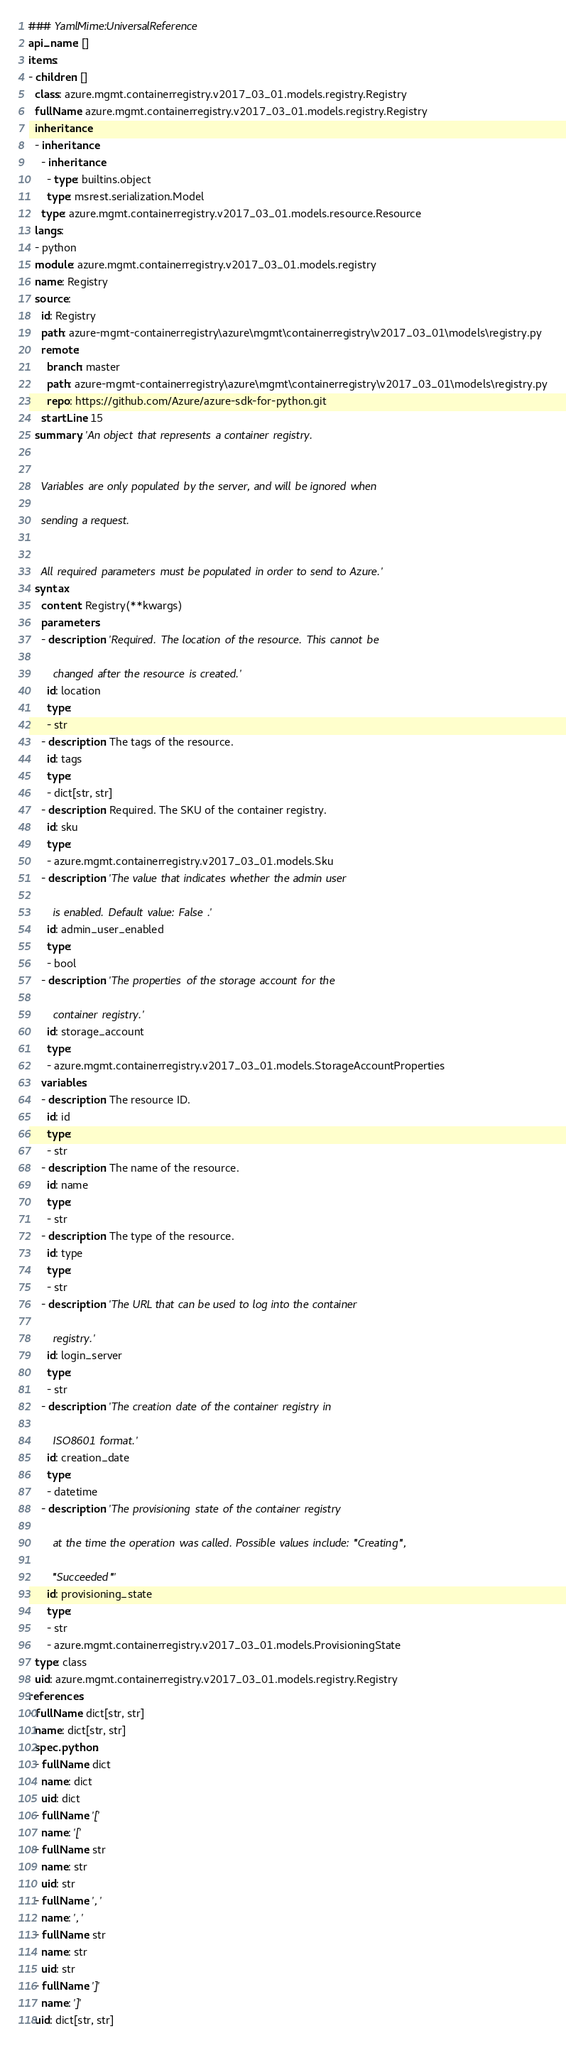Convert code to text. <code><loc_0><loc_0><loc_500><loc_500><_YAML_>### YamlMime:UniversalReference
api_name: []
items:
- children: []
  class: azure.mgmt.containerregistry.v2017_03_01.models.registry.Registry
  fullName: azure.mgmt.containerregistry.v2017_03_01.models.registry.Registry
  inheritance:
  - inheritance:
    - inheritance:
      - type: builtins.object
      type: msrest.serialization.Model
    type: azure.mgmt.containerregistry.v2017_03_01.models.resource.Resource
  langs:
  - python
  module: azure.mgmt.containerregistry.v2017_03_01.models.registry
  name: Registry
  source:
    id: Registry
    path: azure-mgmt-containerregistry\azure\mgmt\containerregistry\v2017_03_01\models\registry.py
    remote:
      branch: master
      path: azure-mgmt-containerregistry\azure\mgmt\containerregistry\v2017_03_01\models\registry.py
      repo: https://github.com/Azure/azure-sdk-for-python.git
    startLine: 15
  summary: 'An object that represents a container registry.


    Variables are only populated by the server, and will be ignored when

    sending a request.


    All required parameters must be populated in order to send to Azure.'
  syntax:
    content: Registry(**kwargs)
    parameters:
    - description: 'Required. The location of the resource. This cannot be

        changed after the resource is created.'
      id: location
      type:
      - str
    - description: The tags of the resource.
      id: tags
      type:
      - dict[str, str]
    - description: Required. The SKU of the container registry.
      id: sku
      type:
      - azure.mgmt.containerregistry.v2017_03_01.models.Sku
    - description: 'The value that indicates whether the admin user

        is enabled. Default value: False .'
      id: admin_user_enabled
      type:
      - bool
    - description: 'The properties of the storage account for the

        container registry.'
      id: storage_account
      type:
      - azure.mgmt.containerregistry.v2017_03_01.models.StorageAccountProperties
    variables:
    - description: The resource ID.
      id: id
      type:
      - str
    - description: The name of the resource.
      id: name
      type:
      - str
    - description: The type of the resource.
      id: type
      type:
      - str
    - description: 'The URL that can be used to log into the container

        registry.'
      id: login_server
      type:
      - str
    - description: 'The creation date of the container registry in

        ISO8601 format.'
      id: creation_date
      type:
      - datetime
    - description: 'The provisioning state of the container registry

        at the time the operation was called. Possible values include: ''Creating'',

        ''Succeeded'''
      id: provisioning_state
      type:
      - str
      - azure.mgmt.containerregistry.v2017_03_01.models.ProvisioningState
  type: class
  uid: azure.mgmt.containerregistry.v2017_03_01.models.registry.Registry
references:
- fullName: dict[str, str]
  name: dict[str, str]
  spec.python:
  - fullName: dict
    name: dict
    uid: dict
  - fullName: '['
    name: '['
  - fullName: str
    name: str
    uid: str
  - fullName: ', '
    name: ', '
  - fullName: str
    name: str
    uid: str
  - fullName: ']'
    name: ']'
  uid: dict[str, str]
</code> 